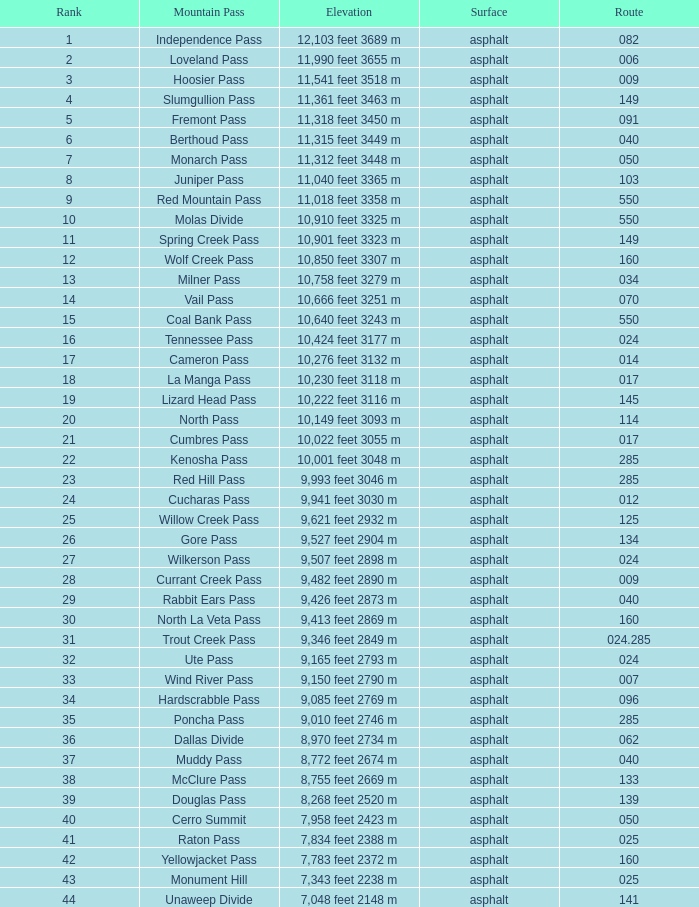On what path is the mountain having a rank under 33 and an altitude of 11,312 feet (3448 m)? 50.0. 